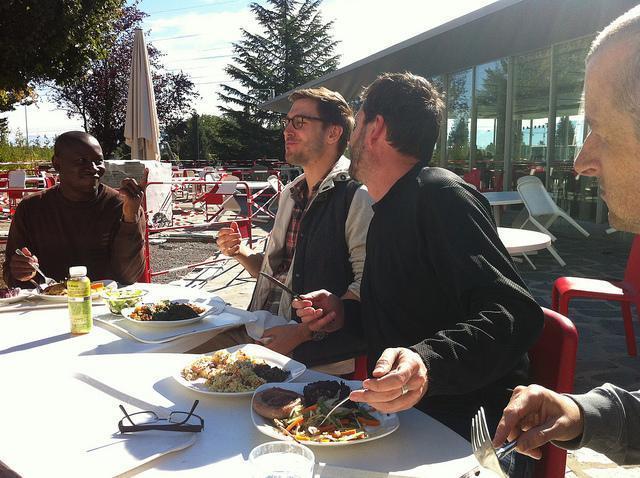How many men are in this picture?
Give a very brief answer. 4. How many dining tables are visible?
Give a very brief answer. 1. How many chairs are in the picture?
Give a very brief answer. 2. How many people are there?
Give a very brief answer. 4. How many train cars are orange?
Give a very brief answer. 0. 